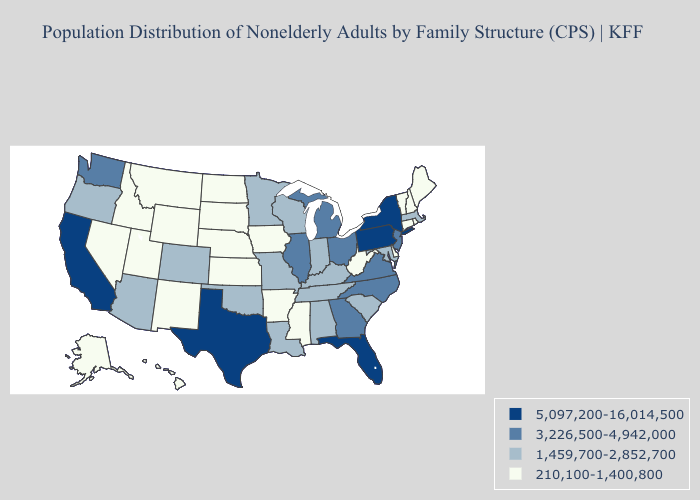Among the states that border New Hampshire , does Maine have the highest value?
Give a very brief answer. No. What is the highest value in states that border North Dakota?
Short answer required. 1,459,700-2,852,700. What is the highest value in the South ?
Write a very short answer. 5,097,200-16,014,500. Does Wisconsin have a lower value than Virginia?
Keep it brief. Yes. What is the lowest value in the MidWest?
Be succinct. 210,100-1,400,800. What is the value of California?
Concise answer only. 5,097,200-16,014,500. Which states hav the highest value in the Northeast?
Quick response, please. New York, Pennsylvania. Which states have the lowest value in the Northeast?
Be succinct. Connecticut, Maine, New Hampshire, Rhode Island, Vermont. Name the states that have a value in the range 210,100-1,400,800?
Write a very short answer. Alaska, Arkansas, Connecticut, Delaware, Hawaii, Idaho, Iowa, Kansas, Maine, Mississippi, Montana, Nebraska, Nevada, New Hampshire, New Mexico, North Dakota, Rhode Island, South Dakota, Utah, Vermont, West Virginia, Wyoming. Does the first symbol in the legend represent the smallest category?
Answer briefly. No. Name the states that have a value in the range 5,097,200-16,014,500?
Write a very short answer. California, Florida, New York, Pennsylvania, Texas. What is the highest value in the USA?
Answer briefly. 5,097,200-16,014,500. What is the highest value in the USA?
Short answer required. 5,097,200-16,014,500. Which states hav the highest value in the West?
Answer briefly. California. Among the states that border Kentucky , does Missouri have the highest value?
Answer briefly. No. 